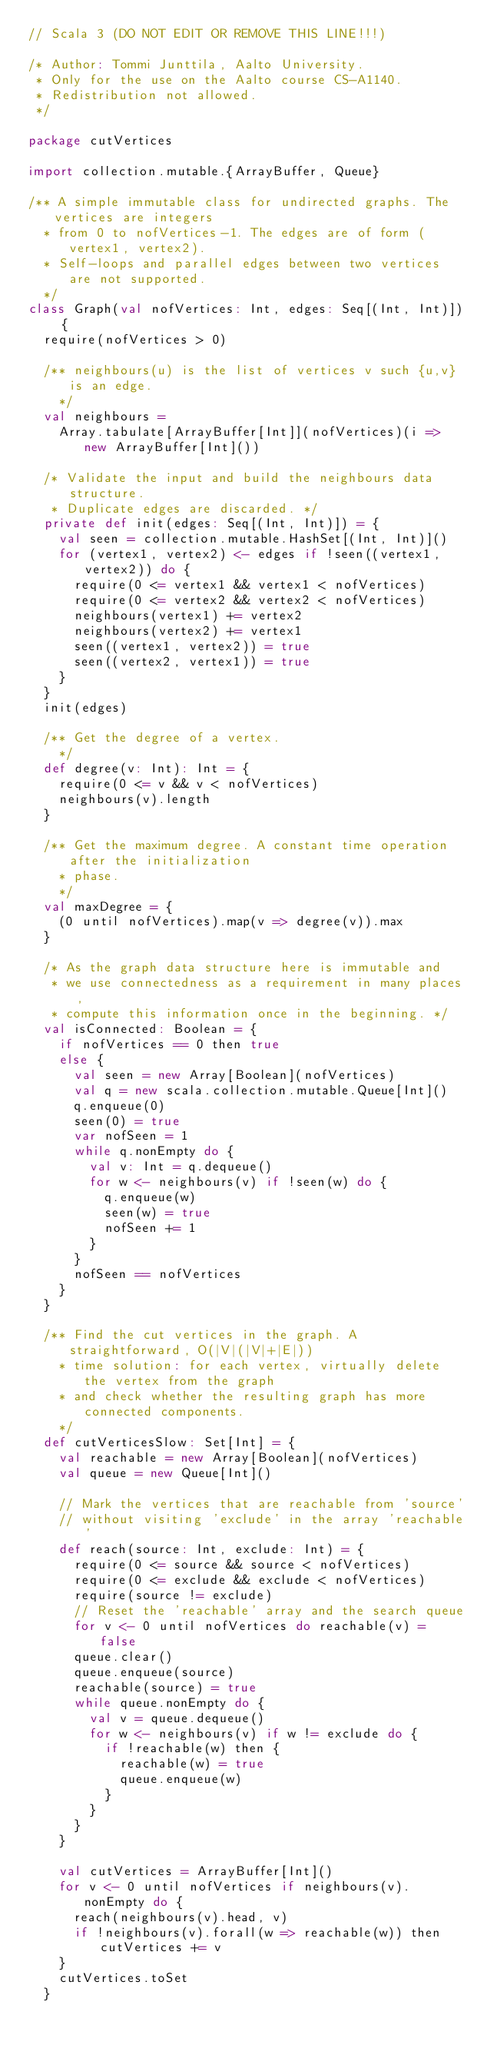<code> <loc_0><loc_0><loc_500><loc_500><_Scala_>// Scala 3 (DO NOT EDIT OR REMOVE THIS LINE!!!)

/* Author: Tommi Junttila, Aalto University.
 * Only for the use on the Aalto course CS-A1140.
 * Redistribution not allowed.
 */

package cutVertices

import collection.mutable.{ArrayBuffer, Queue}

/** A simple immutable class for undirected graphs. The vertices are integers
  * from 0 to nofVertices-1. The edges are of form (vertex1, vertex2).
  * Self-loops and parallel edges between two vertices are not supported.
  */
class Graph(val nofVertices: Int, edges: Seq[(Int, Int)]) {
  require(nofVertices > 0)

  /** neighbours(u) is the list of vertices v such {u,v} is an edge.
    */
  val neighbours =
    Array.tabulate[ArrayBuffer[Int]](nofVertices)(i => new ArrayBuffer[Int]())

  /* Validate the input and build the neighbours data structure.
   * Duplicate edges are discarded. */
  private def init(edges: Seq[(Int, Int)]) = {
    val seen = collection.mutable.HashSet[(Int, Int)]()
    for (vertex1, vertex2) <- edges if !seen((vertex1, vertex2)) do {
      require(0 <= vertex1 && vertex1 < nofVertices)
      require(0 <= vertex2 && vertex2 < nofVertices)
      neighbours(vertex1) += vertex2
      neighbours(vertex2) += vertex1
      seen((vertex1, vertex2)) = true
      seen((vertex2, vertex1)) = true
    }
  }
  init(edges)

  /** Get the degree of a vertex.
    */
  def degree(v: Int): Int = {
    require(0 <= v && v < nofVertices)
    neighbours(v).length
  }

  /** Get the maximum degree. A constant time operation after the initialization
    * phase.
    */
  val maxDegree = {
    (0 until nofVertices).map(v => degree(v)).max
  }

  /* As the graph data structure here is immutable and
   * we use connectedness as a requirement in many places,
   * compute this information once in the beginning. */
  val isConnected: Boolean = {
    if nofVertices == 0 then true
    else {
      val seen = new Array[Boolean](nofVertices)
      val q = new scala.collection.mutable.Queue[Int]()
      q.enqueue(0)
      seen(0) = true
      var nofSeen = 1
      while q.nonEmpty do {
        val v: Int = q.dequeue()
        for w <- neighbours(v) if !seen(w) do {
          q.enqueue(w)
          seen(w) = true
          nofSeen += 1
        }
      }
      nofSeen == nofVertices
    }
  }

  /** Find the cut vertices in the graph. A straightforward, O(|V|(|V|+|E|))
    * time solution: for each vertex, virtually delete the vertex from the graph
    * and check whether the resulting graph has more connected components.
    */
  def cutVerticesSlow: Set[Int] = {
    val reachable = new Array[Boolean](nofVertices)
    val queue = new Queue[Int]()

    // Mark the vertices that are reachable from 'source'
    // without visiting 'exclude' in the array 'reachable'
    def reach(source: Int, exclude: Int) = {
      require(0 <= source && source < nofVertices)
      require(0 <= exclude && exclude < nofVertices)
      require(source != exclude)
      // Reset the 'reachable' array and the search queue
      for v <- 0 until nofVertices do reachable(v) = false
      queue.clear()
      queue.enqueue(source)
      reachable(source) = true
      while queue.nonEmpty do {
        val v = queue.dequeue()
        for w <- neighbours(v) if w != exclude do {
          if !reachable(w) then {
            reachable(w) = true
            queue.enqueue(w)
          }
        }
      }
    }

    val cutVertices = ArrayBuffer[Int]()
    for v <- 0 until nofVertices if neighbours(v).nonEmpty do {
      reach(neighbours(v).head, v)
      if !neighbours(v).forall(w => reachable(w)) then cutVertices += v
    }
    cutVertices.toSet
  }
</code> 